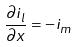<formula> <loc_0><loc_0><loc_500><loc_500>\frac { \partial i _ { l } } { \partial x } = - i _ { m }</formula> 